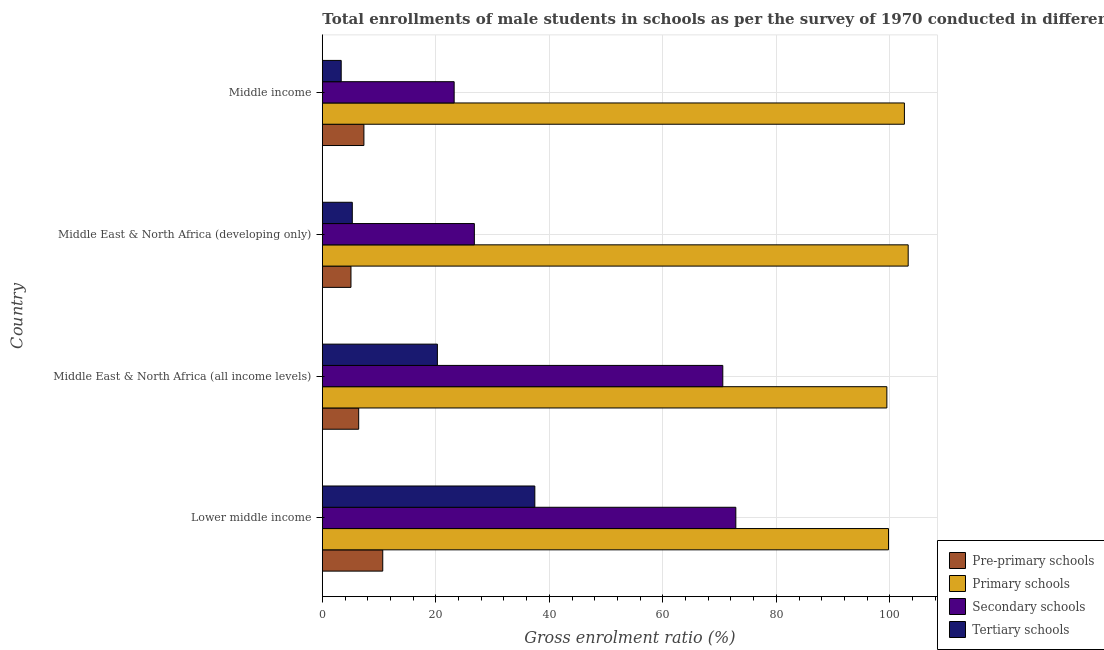How many different coloured bars are there?
Your answer should be very brief. 4. Are the number of bars per tick equal to the number of legend labels?
Provide a short and direct response. Yes. How many bars are there on the 4th tick from the top?
Provide a short and direct response. 4. How many bars are there on the 3rd tick from the bottom?
Your answer should be very brief. 4. What is the label of the 4th group of bars from the top?
Ensure brevity in your answer.  Lower middle income. What is the gross enrolment ratio(male) in tertiary schools in Middle income?
Offer a terse response. 3.32. Across all countries, what is the maximum gross enrolment ratio(male) in primary schools?
Provide a succinct answer. 103.23. Across all countries, what is the minimum gross enrolment ratio(male) in tertiary schools?
Make the answer very short. 3.32. In which country was the gross enrolment ratio(male) in primary schools maximum?
Provide a succinct answer. Middle East & North Africa (developing only). In which country was the gross enrolment ratio(male) in pre-primary schools minimum?
Keep it short and to the point. Middle East & North Africa (developing only). What is the total gross enrolment ratio(male) in tertiary schools in the graph?
Offer a very short reply. 66.32. What is the difference between the gross enrolment ratio(male) in primary schools in Lower middle income and that in Middle East & North Africa (developing only)?
Give a very brief answer. -3.47. What is the difference between the gross enrolment ratio(male) in primary schools in Lower middle income and the gross enrolment ratio(male) in pre-primary schools in Middle East & North Africa (developing only)?
Your response must be concise. 94.71. What is the average gross enrolment ratio(male) in primary schools per country?
Provide a succinct answer. 101.25. What is the difference between the gross enrolment ratio(male) in primary schools and gross enrolment ratio(male) in pre-primary schools in Lower middle income?
Provide a short and direct response. 89.11. What is the ratio of the gross enrolment ratio(male) in pre-primary schools in Middle East & North Africa (all income levels) to that in Middle East & North Africa (developing only)?
Make the answer very short. 1.27. What is the difference between the highest and the second highest gross enrolment ratio(male) in secondary schools?
Provide a short and direct response. 2.3. What is the difference between the highest and the lowest gross enrolment ratio(male) in secondary schools?
Provide a short and direct response. 49.63. In how many countries, is the gross enrolment ratio(male) in tertiary schools greater than the average gross enrolment ratio(male) in tertiary schools taken over all countries?
Your response must be concise. 2. Is the sum of the gross enrolment ratio(male) in tertiary schools in Middle East & North Africa (all income levels) and Middle income greater than the maximum gross enrolment ratio(male) in pre-primary schools across all countries?
Give a very brief answer. Yes. Is it the case that in every country, the sum of the gross enrolment ratio(male) in tertiary schools and gross enrolment ratio(male) in secondary schools is greater than the sum of gross enrolment ratio(male) in primary schools and gross enrolment ratio(male) in pre-primary schools?
Your response must be concise. Yes. What does the 4th bar from the top in Lower middle income represents?
Offer a very short reply. Pre-primary schools. What does the 3rd bar from the bottom in Middle East & North Africa (all income levels) represents?
Offer a terse response. Secondary schools. Is it the case that in every country, the sum of the gross enrolment ratio(male) in pre-primary schools and gross enrolment ratio(male) in primary schools is greater than the gross enrolment ratio(male) in secondary schools?
Your answer should be very brief. Yes. Are all the bars in the graph horizontal?
Ensure brevity in your answer.  Yes. Does the graph contain any zero values?
Offer a very short reply. No. How many legend labels are there?
Your answer should be very brief. 4. What is the title of the graph?
Offer a terse response. Total enrollments of male students in schools as per the survey of 1970 conducted in different countries. Does "Secondary schools" appear as one of the legend labels in the graph?
Your answer should be very brief. Yes. What is the label or title of the X-axis?
Make the answer very short. Gross enrolment ratio (%). What is the label or title of the Y-axis?
Give a very brief answer. Country. What is the Gross enrolment ratio (%) of Pre-primary schools in Lower middle income?
Your answer should be compact. 10.65. What is the Gross enrolment ratio (%) of Primary schools in Lower middle income?
Give a very brief answer. 99.76. What is the Gross enrolment ratio (%) of Secondary schools in Lower middle income?
Offer a very short reply. 72.86. What is the Gross enrolment ratio (%) in Tertiary schools in Lower middle income?
Your answer should be compact. 37.44. What is the Gross enrolment ratio (%) in Pre-primary schools in Middle East & North Africa (all income levels)?
Give a very brief answer. 6.41. What is the Gross enrolment ratio (%) of Primary schools in Middle East & North Africa (all income levels)?
Ensure brevity in your answer.  99.47. What is the Gross enrolment ratio (%) in Secondary schools in Middle East & North Africa (all income levels)?
Keep it short and to the point. 70.56. What is the Gross enrolment ratio (%) of Tertiary schools in Middle East & North Africa (all income levels)?
Your response must be concise. 20.27. What is the Gross enrolment ratio (%) of Pre-primary schools in Middle East & North Africa (developing only)?
Ensure brevity in your answer.  5.05. What is the Gross enrolment ratio (%) in Primary schools in Middle East & North Africa (developing only)?
Offer a terse response. 103.23. What is the Gross enrolment ratio (%) in Secondary schools in Middle East & North Africa (developing only)?
Ensure brevity in your answer.  26.79. What is the Gross enrolment ratio (%) in Tertiary schools in Middle East & North Africa (developing only)?
Offer a very short reply. 5.28. What is the Gross enrolment ratio (%) in Pre-primary schools in Middle income?
Offer a very short reply. 7.33. What is the Gross enrolment ratio (%) of Primary schools in Middle income?
Your answer should be compact. 102.56. What is the Gross enrolment ratio (%) in Secondary schools in Middle income?
Give a very brief answer. 23.23. What is the Gross enrolment ratio (%) in Tertiary schools in Middle income?
Your answer should be very brief. 3.32. Across all countries, what is the maximum Gross enrolment ratio (%) in Pre-primary schools?
Ensure brevity in your answer.  10.65. Across all countries, what is the maximum Gross enrolment ratio (%) in Primary schools?
Provide a succinct answer. 103.23. Across all countries, what is the maximum Gross enrolment ratio (%) in Secondary schools?
Offer a very short reply. 72.86. Across all countries, what is the maximum Gross enrolment ratio (%) in Tertiary schools?
Make the answer very short. 37.44. Across all countries, what is the minimum Gross enrolment ratio (%) in Pre-primary schools?
Your answer should be very brief. 5.05. Across all countries, what is the minimum Gross enrolment ratio (%) in Primary schools?
Your answer should be compact. 99.47. Across all countries, what is the minimum Gross enrolment ratio (%) in Secondary schools?
Ensure brevity in your answer.  23.23. Across all countries, what is the minimum Gross enrolment ratio (%) in Tertiary schools?
Provide a short and direct response. 3.32. What is the total Gross enrolment ratio (%) in Pre-primary schools in the graph?
Your answer should be compact. 29.43. What is the total Gross enrolment ratio (%) in Primary schools in the graph?
Make the answer very short. 405.01. What is the total Gross enrolment ratio (%) of Secondary schools in the graph?
Your response must be concise. 193.43. What is the total Gross enrolment ratio (%) of Tertiary schools in the graph?
Offer a very short reply. 66.32. What is the difference between the Gross enrolment ratio (%) in Pre-primary schools in Lower middle income and that in Middle East & North Africa (all income levels)?
Keep it short and to the point. 4.24. What is the difference between the Gross enrolment ratio (%) of Primary schools in Lower middle income and that in Middle East & North Africa (all income levels)?
Offer a very short reply. 0.29. What is the difference between the Gross enrolment ratio (%) in Secondary schools in Lower middle income and that in Middle East & North Africa (all income levels)?
Provide a short and direct response. 2.3. What is the difference between the Gross enrolment ratio (%) in Tertiary schools in Lower middle income and that in Middle East & North Africa (all income levels)?
Keep it short and to the point. 17.17. What is the difference between the Gross enrolment ratio (%) of Pre-primary schools in Lower middle income and that in Middle East & North Africa (developing only)?
Make the answer very short. 5.6. What is the difference between the Gross enrolment ratio (%) in Primary schools in Lower middle income and that in Middle East & North Africa (developing only)?
Make the answer very short. -3.47. What is the difference between the Gross enrolment ratio (%) of Secondary schools in Lower middle income and that in Middle East & North Africa (developing only)?
Your response must be concise. 46.07. What is the difference between the Gross enrolment ratio (%) in Tertiary schools in Lower middle income and that in Middle East & North Africa (developing only)?
Make the answer very short. 32.16. What is the difference between the Gross enrolment ratio (%) of Pre-primary schools in Lower middle income and that in Middle income?
Ensure brevity in your answer.  3.32. What is the difference between the Gross enrolment ratio (%) of Primary schools in Lower middle income and that in Middle income?
Provide a succinct answer. -2.81. What is the difference between the Gross enrolment ratio (%) of Secondary schools in Lower middle income and that in Middle income?
Your answer should be very brief. 49.63. What is the difference between the Gross enrolment ratio (%) of Tertiary schools in Lower middle income and that in Middle income?
Your response must be concise. 34.12. What is the difference between the Gross enrolment ratio (%) in Pre-primary schools in Middle East & North Africa (all income levels) and that in Middle East & North Africa (developing only)?
Keep it short and to the point. 1.36. What is the difference between the Gross enrolment ratio (%) in Primary schools in Middle East & North Africa (all income levels) and that in Middle East & North Africa (developing only)?
Provide a succinct answer. -3.76. What is the difference between the Gross enrolment ratio (%) in Secondary schools in Middle East & North Africa (all income levels) and that in Middle East & North Africa (developing only)?
Your answer should be very brief. 43.77. What is the difference between the Gross enrolment ratio (%) of Tertiary schools in Middle East & North Africa (all income levels) and that in Middle East & North Africa (developing only)?
Keep it short and to the point. 14.99. What is the difference between the Gross enrolment ratio (%) of Pre-primary schools in Middle East & North Africa (all income levels) and that in Middle income?
Ensure brevity in your answer.  -0.92. What is the difference between the Gross enrolment ratio (%) in Primary schools in Middle East & North Africa (all income levels) and that in Middle income?
Your answer should be very brief. -3.09. What is the difference between the Gross enrolment ratio (%) of Secondary schools in Middle East & North Africa (all income levels) and that in Middle income?
Give a very brief answer. 47.33. What is the difference between the Gross enrolment ratio (%) of Tertiary schools in Middle East & North Africa (all income levels) and that in Middle income?
Your answer should be compact. 16.95. What is the difference between the Gross enrolment ratio (%) in Pre-primary schools in Middle East & North Africa (developing only) and that in Middle income?
Provide a short and direct response. -2.28. What is the difference between the Gross enrolment ratio (%) in Primary schools in Middle East & North Africa (developing only) and that in Middle income?
Your answer should be compact. 0.66. What is the difference between the Gross enrolment ratio (%) in Secondary schools in Middle East & North Africa (developing only) and that in Middle income?
Offer a terse response. 3.56. What is the difference between the Gross enrolment ratio (%) of Tertiary schools in Middle East & North Africa (developing only) and that in Middle income?
Provide a short and direct response. 1.95. What is the difference between the Gross enrolment ratio (%) of Pre-primary schools in Lower middle income and the Gross enrolment ratio (%) of Primary schools in Middle East & North Africa (all income levels)?
Keep it short and to the point. -88.82. What is the difference between the Gross enrolment ratio (%) in Pre-primary schools in Lower middle income and the Gross enrolment ratio (%) in Secondary schools in Middle East & North Africa (all income levels)?
Provide a succinct answer. -59.91. What is the difference between the Gross enrolment ratio (%) of Pre-primary schools in Lower middle income and the Gross enrolment ratio (%) of Tertiary schools in Middle East & North Africa (all income levels)?
Your response must be concise. -9.63. What is the difference between the Gross enrolment ratio (%) in Primary schools in Lower middle income and the Gross enrolment ratio (%) in Secondary schools in Middle East & North Africa (all income levels)?
Your answer should be very brief. 29.2. What is the difference between the Gross enrolment ratio (%) in Primary schools in Lower middle income and the Gross enrolment ratio (%) in Tertiary schools in Middle East & North Africa (all income levels)?
Provide a short and direct response. 79.48. What is the difference between the Gross enrolment ratio (%) in Secondary schools in Lower middle income and the Gross enrolment ratio (%) in Tertiary schools in Middle East & North Africa (all income levels)?
Make the answer very short. 52.58. What is the difference between the Gross enrolment ratio (%) of Pre-primary schools in Lower middle income and the Gross enrolment ratio (%) of Primary schools in Middle East & North Africa (developing only)?
Your answer should be very brief. -92.58. What is the difference between the Gross enrolment ratio (%) in Pre-primary schools in Lower middle income and the Gross enrolment ratio (%) in Secondary schools in Middle East & North Africa (developing only)?
Your answer should be compact. -16.14. What is the difference between the Gross enrolment ratio (%) in Pre-primary schools in Lower middle income and the Gross enrolment ratio (%) in Tertiary schools in Middle East & North Africa (developing only)?
Provide a succinct answer. 5.37. What is the difference between the Gross enrolment ratio (%) in Primary schools in Lower middle income and the Gross enrolment ratio (%) in Secondary schools in Middle East & North Africa (developing only)?
Give a very brief answer. 72.97. What is the difference between the Gross enrolment ratio (%) in Primary schools in Lower middle income and the Gross enrolment ratio (%) in Tertiary schools in Middle East & North Africa (developing only)?
Provide a short and direct response. 94.48. What is the difference between the Gross enrolment ratio (%) in Secondary schools in Lower middle income and the Gross enrolment ratio (%) in Tertiary schools in Middle East & North Africa (developing only)?
Your response must be concise. 67.58. What is the difference between the Gross enrolment ratio (%) of Pre-primary schools in Lower middle income and the Gross enrolment ratio (%) of Primary schools in Middle income?
Keep it short and to the point. -91.91. What is the difference between the Gross enrolment ratio (%) of Pre-primary schools in Lower middle income and the Gross enrolment ratio (%) of Secondary schools in Middle income?
Ensure brevity in your answer.  -12.58. What is the difference between the Gross enrolment ratio (%) of Pre-primary schools in Lower middle income and the Gross enrolment ratio (%) of Tertiary schools in Middle income?
Offer a terse response. 7.32. What is the difference between the Gross enrolment ratio (%) of Primary schools in Lower middle income and the Gross enrolment ratio (%) of Secondary schools in Middle income?
Make the answer very short. 76.53. What is the difference between the Gross enrolment ratio (%) in Primary schools in Lower middle income and the Gross enrolment ratio (%) in Tertiary schools in Middle income?
Provide a short and direct response. 96.43. What is the difference between the Gross enrolment ratio (%) in Secondary schools in Lower middle income and the Gross enrolment ratio (%) in Tertiary schools in Middle income?
Make the answer very short. 69.53. What is the difference between the Gross enrolment ratio (%) of Pre-primary schools in Middle East & North Africa (all income levels) and the Gross enrolment ratio (%) of Primary schools in Middle East & North Africa (developing only)?
Give a very brief answer. -96.82. What is the difference between the Gross enrolment ratio (%) of Pre-primary schools in Middle East & North Africa (all income levels) and the Gross enrolment ratio (%) of Secondary schools in Middle East & North Africa (developing only)?
Offer a very short reply. -20.38. What is the difference between the Gross enrolment ratio (%) in Pre-primary schools in Middle East & North Africa (all income levels) and the Gross enrolment ratio (%) in Tertiary schools in Middle East & North Africa (developing only)?
Ensure brevity in your answer.  1.13. What is the difference between the Gross enrolment ratio (%) of Primary schools in Middle East & North Africa (all income levels) and the Gross enrolment ratio (%) of Secondary schools in Middle East & North Africa (developing only)?
Make the answer very short. 72.68. What is the difference between the Gross enrolment ratio (%) in Primary schools in Middle East & North Africa (all income levels) and the Gross enrolment ratio (%) in Tertiary schools in Middle East & North Africa (developing only)?
Make the answer very short. 94.19. What is the difference between the Gross enrolment ratio (%) in Secondary schools in Middle East & North Africa (all income levels) and the Gross enrolment ratio (%) in Tertiary schools in Middle East & North Africa (developing only)?
Your answer should be compact. 65.28. What is the difference between the Gross enrolment ratio (%) of Pre-primary schools in Middle East & North Africa (all income levels) and the Gross enrolment ratio (%) of Primary schools in Middle income?
Your answer should be very brief. -96.15. What is the difference between the Gross enrolment ratio (%) of Pre-primary schools in Middle East & North Africa (all income levels) and the Gross enrolment ratio (%) of Secondary schools in Middle income?
Provide a succinct answer. -16.82. What is the difference between the Gross enrolment ratio (%) in Pre-primary schools in Middle East & North Africa (all income levels) and the Gross enrolment ratio (%) in Tertiary schools in Middle income?
Your answer should be very brief. 3.08. What is the difference between the Gross enrolment ratio (%) of Primary schools in Middle East & North Africa (all income levels) and the Gross enrolment ratio (%) of Secondary schools in Middle income?
Provide a succinct answer. 76.24. What is the difference between the Gross enrolment ratio (%) in Primary schools in Middle East & North Africa (all income levels) and the Gross enrolment ratio (%) in Tertiary schools in Middle income?
Offer a very short reply. 96.14. What is the difference between the Gross enrolment ratio (%) in Secondary schools in Middle East & North Africa (all income levels) and the Gross enrolment ratio (%) in Tertiary schools in Middle income?
Offer a terse response. 67.24. What is the difference between the Gross enrolment ratio (%) of Pre-primary schools in Middle East & North Africa (developing only) and the Gross enrolment ratio (%) of Primary schools in Middle income?
Provide a short and direct response. -97.51. What is the difference between the Gross enrolment ratio (%) of Pre-primary schools in Middle East & North Africa (developing only) and the Gross enrolment ratio (%) of Secondary schools in Middle income?
Give a very brief answer. -18.18. What is the difference between the Gross enrolment ratio (%) in Pre-primary schools in Middle East & North Africa (developing only) and the Gross enrolment ratio (%) in Tertiary schools in Middle income?
Keep it short and to the point. 1.72. What is the difference between the Gross enrolment ratio (%) of Primary schools in Middle East & North Africa (developing only) and the Gross enrolment ratio (%) of Secondary schools in Middle income?
Ensure brevity in your answer.  80. What is the difference between the Gross enrolment ratio (%) in Primary schools in Middle East & North Africa (developing only) and the Gross enrolment ratio (%) in Tertiary schools in Middle income?
Provide a short and direct response. 99.9. What is the difference between the Gross enrolment ratio (%) in Secondary schools in Middle East & North Africa (developing only) and the Gross enrolment ratio (%) in Tertiary schools in Middle income?
Offer a terse response. 23.46. What is the average Gross enrolment ratio (%) of Pre-primary schools per country?
Provide a succinct answer. 7.36. What is the average Gross enrolment ratio (%) of Primary schools per country?
Keep it short and to the point. 101.25. What is the average Gross enrolment ratio (%) of Secondary schools per country?
Make the answer very short. 48.36. What is the average Gross enrolment ratio (%) in Tertiary schools per country?
Keep it short and to the point. 16.58. What is the difference between the Gross enrolment ratio (%) in Pre-primary schools and Gross enrolment ratio (%) in Primary schools in Lower middle income?
Your response must be concise. -89.11. What is the difference between the Gross enrolment ratio (%) in Pre-primary schools and Gross enrolment ratio (%) in Secondary schools in Lower middle income?
Your answer should be very brief. -62.21. What is the difference between the Gross enrolment ratio (%) of Pre-primary schools and Gross enrolment ratio (%) of Tertiary schools in Lower middle income?
Keep it short and to the point. -26.8. What is the difference between the Gross enrolment ratio (%) in Primary schools and Gross enrolment ratio (%) in Secondary schools in Lower middle income?
Give a very brief answer. 26.9. What is the difference between the Gross enrolment ratio (%) of Primary schools and Gross enrolment ratio (%) of Tertiary schools in Lower middle income?
Make the answer very short. 62.31. What is the difference between the Gross enrolment ratio (%) in Secondary schools and Gross enrolment ratio (%) in Tertiary schools in Lower middle income?
Provide a succinct answer. 35.41. What is the difference between the Gross enrolment ratio (%) in Pre-primary schools and Gross enrolment ratio (%) in Primary schools in Middle East & North Africa (all income levels)?
Your response must be concise. -93.06. What is the difference between the Gross enrolment ratio (%) in Pre-primary schools and Gross enrolment ratio (%) in Secondary schools in Middle East & North Africa (all income levels)?
Give a very brief answer. -64.15. What is the difference between the Gross enrolment ratio (%) of Pre-primary schools and Gross enrolment ratio (%) of Tertiary schools in Middle East & North Africa (all income levels)?
Provide a short and direct response. -13.87. What is the difference between the Gross enrolment ratio (%) in Primary schools and Gross enrolment ratio (%) in Secondary schools in Middle East & North Africa (all income levels)?
Provide a short and direct response. 28.91. What is the difference between the Gross enrolment ratio (%) of Primary schools and Gross enrolment ratio (%) of Tertiary schools in Middle East & North Africa (all income levels)?
Ensure brevity in your answer.  79.19. What is the difference between the Gross enrolment ratio (%) in Secondary schools and Gross enrolment ratio (%) in Tertiary schools in Middle East & North Africa (all income levels)?
Provide a short and direct response. 50.29. What is the difference between the Gross enrolment ratio (%) of Pre-primary schools and Gross enrolment ratio (%) of Primary schools in Middle East & North Africa (developing only)?
Provide a short and direct response. -98.18. What is the difference between the Gross enrolment ratio (%) in Pre-primary schools and Gross enrolment ratio (%) in Secondary schools in Middle East & North Africa (developing only)?
Provide a short and direct response. -21.74. What is the difference between the Gross enrolment ratio (%) of Pre-primary schools and Gross enrolment ratio (%) of Tertiary schools in Middle East & North Africa (developing only)?
Offer a very short reply. -0.23. What is the difference between the Gross enrolment ratio (%) in Primary schools and Gross enrolment ratio (%) in Secondary schools in Middle East & North Africa (developing only)?
Offer a terse response. 76.44. What is the difference between the Gross enrolment ratio (%) in Primary schools and Gross enrolment ratio (%) in Tertiary schools in Middle East & North Africa (developing only)?
Offer a very short reply. 97.95. What is the difference between the Gross enrolment ratio (%) in Secondary schools and Gross enrolment ratio (%) in Tertiary schools in Middle East & North Africa (developing only)?
Offer a very short reply. 21.51. What is the difference between the Gross enrolment ratio (%) in Pre-primary schools and Gross enrolment ratio (%) in Primary schools in Middle income?
Provide a short and direct response. -95.24. What is the difference between the Gross enrolment ratio (%) in Pre-primary schools and Gross enrolment ratio (%) in Secondary schools in Middle income?
Ensure brevity in your answer.  -15.9. What is the difference between the Gross enrolment ratio (%) of Pre-primary schools and Gross enrolment ratio (%) of Tertiary schools in Middle income?
Offer a terse response. 4. What is the difference between the Gross enrolment ratio (%) of Primary schools and Gross enrolment ratio (%) of Secondary schools in Middle income?
Make the answer very short. 79.33. What is the difference between the Gross enrolment ratio (%) of Primary schools and Gross enrolment ratio (%) of Tertiary schools in Middle income?
Give a very brief answer. 99.24. What is the difference between the Gross enrolment ratio (%) of Secondary schools and Gross enrolment ratio (%) of Tertiary schools in Middle income?
Offer a very short reply. 19.9. What is the ratio of the Gross enrolment ratio (%) in Pre-primary schools in Lower middle income to that in Middle East & North Africa (all income levels)?
Provide a succinct answer. 1.66. What is the ratio of the Gross enrolment ratio (%) of Secondary schools in Lower middle income to that in Middle East & North Africa (all income levels)?
Ensure brevity in your answer.  1.03. What is the ratio of the Gross enrolment ratio (%) in Tertiary schools in Lower middle income to that in Middle East & North Africa (all income levels)?
Make the answer very short. 1.85. What is the ratio of the Gross enrolment ratio (%) in Pre-primary schools in Lower middle income to that in Middle East & North Africa (developing only)?
Provide a succinct answer. 2.11. What is the ratio of the Gross enrolment ratio (%) of Primary schools in Lower middle income to that in Middle East & North Africa (developing only)?
Provide a short and direct response. 0.97. What is the ratio of the Gross enrolment ratio (%) in Secondary schools in Lower middle income to that in Middle East & North Africa (developing only)?
Provide a succinct answer. 2.72. What is the ratio of the Gross enrolment ratio (%) of Tertiary schools in Lower middle income to that in Middle East & North Africa (developing only)?
Offer a very short reply. 7.09. What is the ratio of the Gross enrolment ratio (%) in Pre-primary schools in Lower middle income to that in Middle income?
Provide a short and direct response. 1.45. What is the ratio of the Gross enrolment ratio (%) of Primary schools in Lower middle income to that in Middle income?
Your response must be concise. 0.97. What is the ratio of the Gross enrolment ratio (%) in Secondary schools in Lower middle income to that in Middle income?
Provide a succinct answer. 3.14. What is the ratio of the Gross enrolment ratio (%) in Tertiary schools in Lower middle income to that in Middle income?
Give a very brief answer. 11.26. What is the ratio of the Gross enrolment ratio (%) in Pre-primary schools in Middle East & North Africa (all income levels) to that in Middle East & North Africa (developing only)?
Make the answer very short. 1.27. What is the ratio of the Gross enrolment ratio (%) of Primary schools in Middle East & North Africa (all income levels) to that in Middle East & North Africa (developing only)?
Ensure brevity in your answer.  0.96. What is the ratio of the Gross enrolment ratio (%) of Secondary schools in Middle East & North Africa (all income levels) to that in Middle East & North Africa (developing only)?
Your response must be concise. 2.63. What is the ratio of the Gross enrolment ratio (%) in Tertiary schools in Middle East & North Africa (all income levels) to that in Middle East & North Africa (developing only)?
Give a very brief answer. 3.84. What is the ratio of the Gross enrolment ratio (%) in Pre-primary schools in Middle East & North Africa (all income levels) to that in Middle income?
Ensure brevity in your answer.  0.87. What is the ratio of the Gross enrolment ratio (%) in Primary schools in Middle East & North Africa (all income levels) to that in Middle income?
Offer a terse response. 0.97. What is the ratio of the Gross enrolment ratio (%) of Secondary schools in Middle East & North Africa (all income levels) to that in Middle income?
Provide a short and direct response. 3.04. What is the ratio of the Gross enrolment ratio (%) of Tertiary schools in Middle East & North Africa (all income levels) to that in Middle income?
Your answer should be compact. 6.1. What is the ratio of the Gross enrolment ratio (%) of Pre-primary schools in Middle East & North Africa (developing only) to that in Middle income?
Make the answer very short. 0.69. What is the ratio of the Gross enrolment ratio (%) in Secondary schools in Middle East & North Africa (developing only) to that in Middle income?
Make the answer very short. 1.15. What is the ratio of the Gross enrolment ratio (%) of Tertiary schools in Middle East & North Africa (developing only) to that in Middle income?
Provide a short and direct response. 1.59. What is the difference between the highest and the second highest Gross enrolment ratio (%) in Pre-primary schools?
Your answer should be compact. 3.32. What is the difference between the highest and the second highest Gross enrolment ratio (%) in Primary schools?
Offer a terse response. 0.66. What is the difference between the highest and the second highest Gross enrolment ratio (%) in Secondary schools?
Your answer should be very brief. 2.3. What is the difference between the highest and the second highest Gross enrolment ratio (%) of Tertiary schools?
Your answer should be compact. 17.17. What is the difference between the highest and the lowest Gross enrolment ratio (%) of Pre-primary schools?
Ensure brevity in your answer.  5.6. What is the difference between the highest and the lowest Gross enrolment ratio (%) in Primary schools?
Keep it short and to the point. 3.76. What is the difference between the highest and the lowest Gross enrolment ratio (%) of Secondary schools?
Your answer should be compact. 49.63. What is the difference between the highest and the lowest Gross enrolment ratio (%) in Tertiary schools?
Keep it short and to the point. 34.12. 